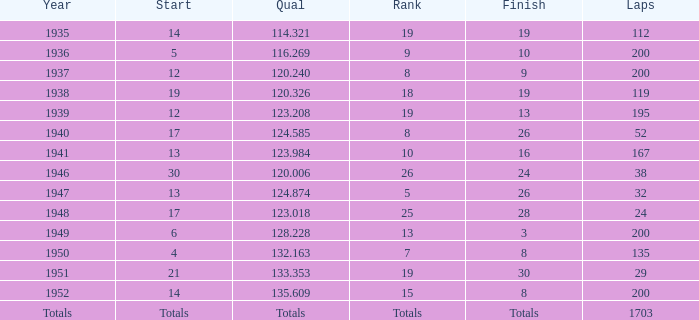006 conducted in? 1946.0. Give me the full table as a dictionary. {'header': ['Year', 'Start', 'Qual', 'Rank', 'Finish', 'Laps'], 'rows': [['1935', '14', '114.321', '19', '19', '112'], ['1936', '5', '116.269', '9', '10', '200'], ['1937', '12', '120.240', '8', '9', '200'], ['1938', '19', '120.326', '18', '19', '119'], ['1939', '12', '123.208', '19', '13', '195'], ['1940', '17', '124.585', '8', '26', '52'], ['1941', '13', '123.984', '10', '16', '167'], ['1946', '30', '120.006', '26', '24', '38'], ['1947', '13', '124.874', '5', '26', '32'], ['1948', '17', '123.018', '25', '28', '24'], ['1949', '6', '128.228', '13', '3', '200'], ['1950', '4', '132.163', '7', '8', '135'], ['1951', '21', '133.353', '19', '30', '29'], ['1952', '14', '135.609', '15', '8', '200'], ['Totals', 'Totals', 'Totals', 'Totals', 'Totals', '1703']]} 